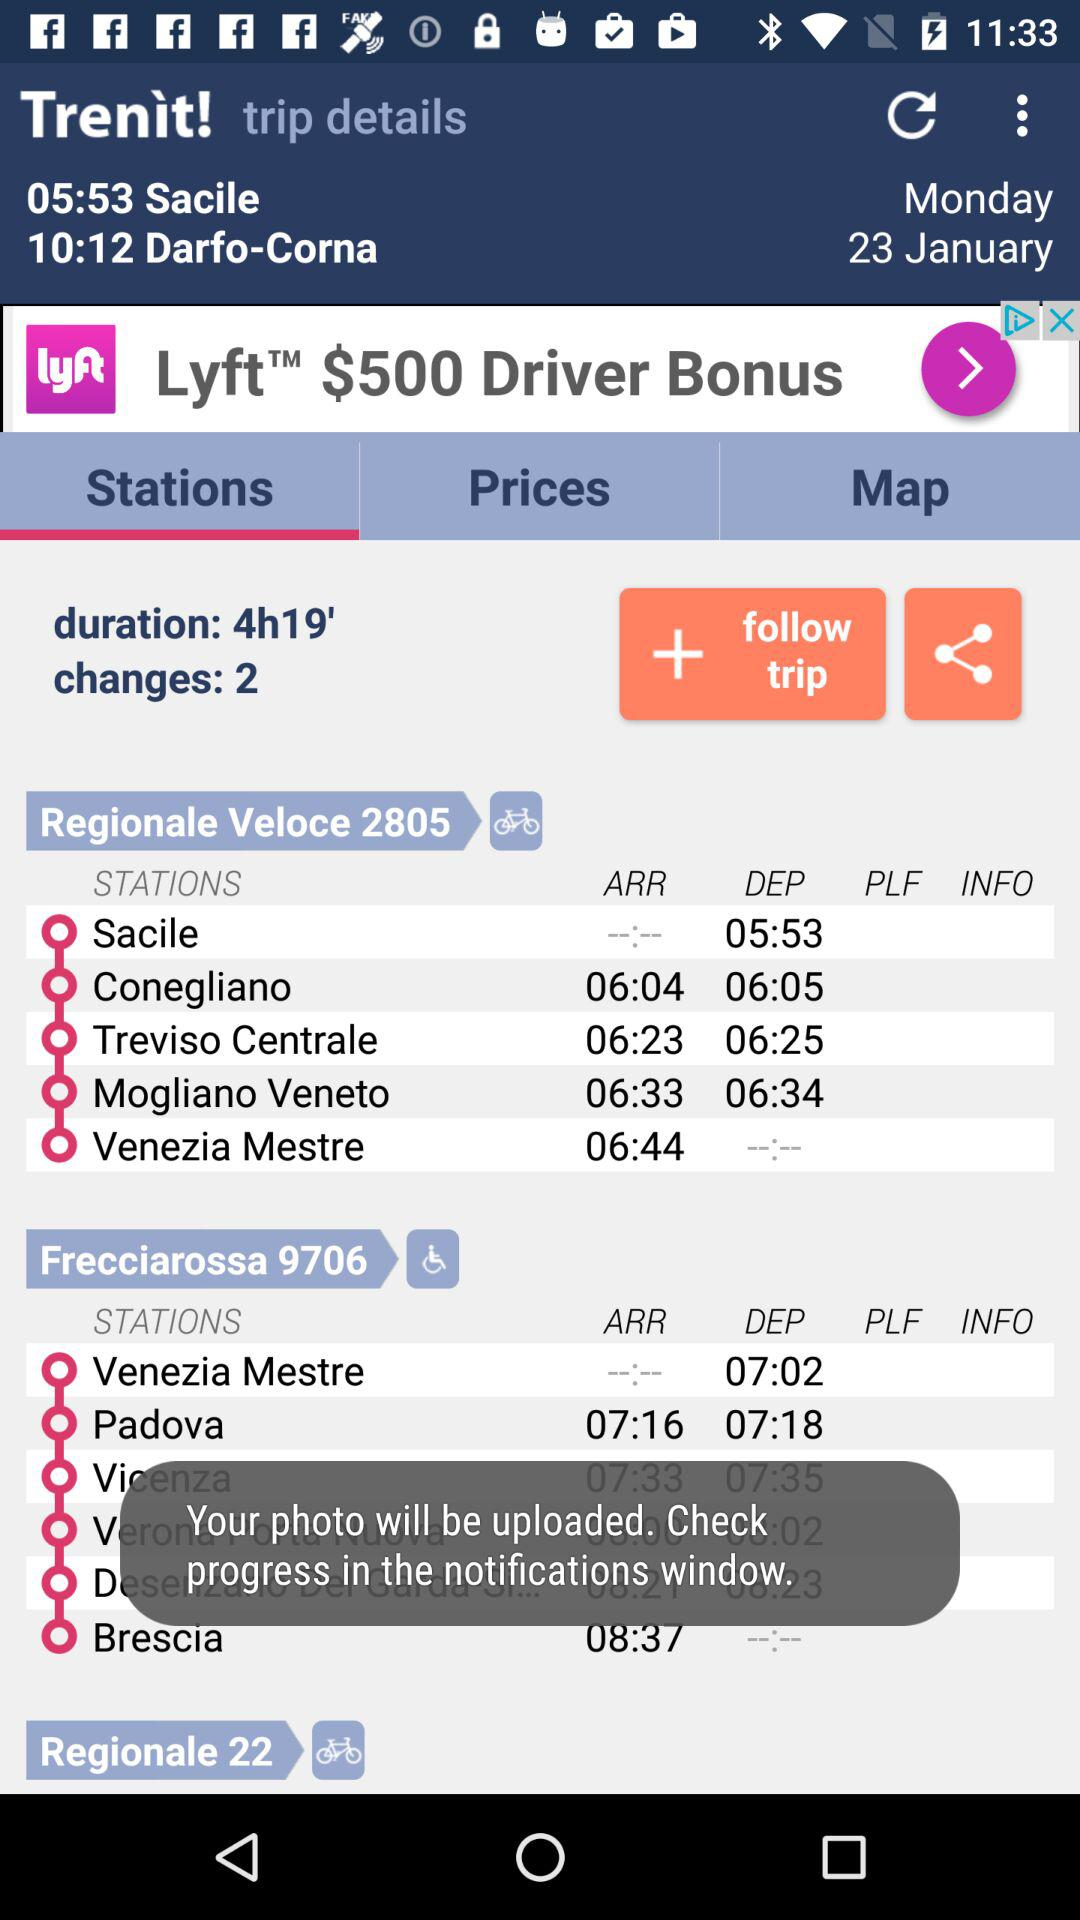What is the duration of the journey? The duration of the journey is 4 hours and 19 minutes. 